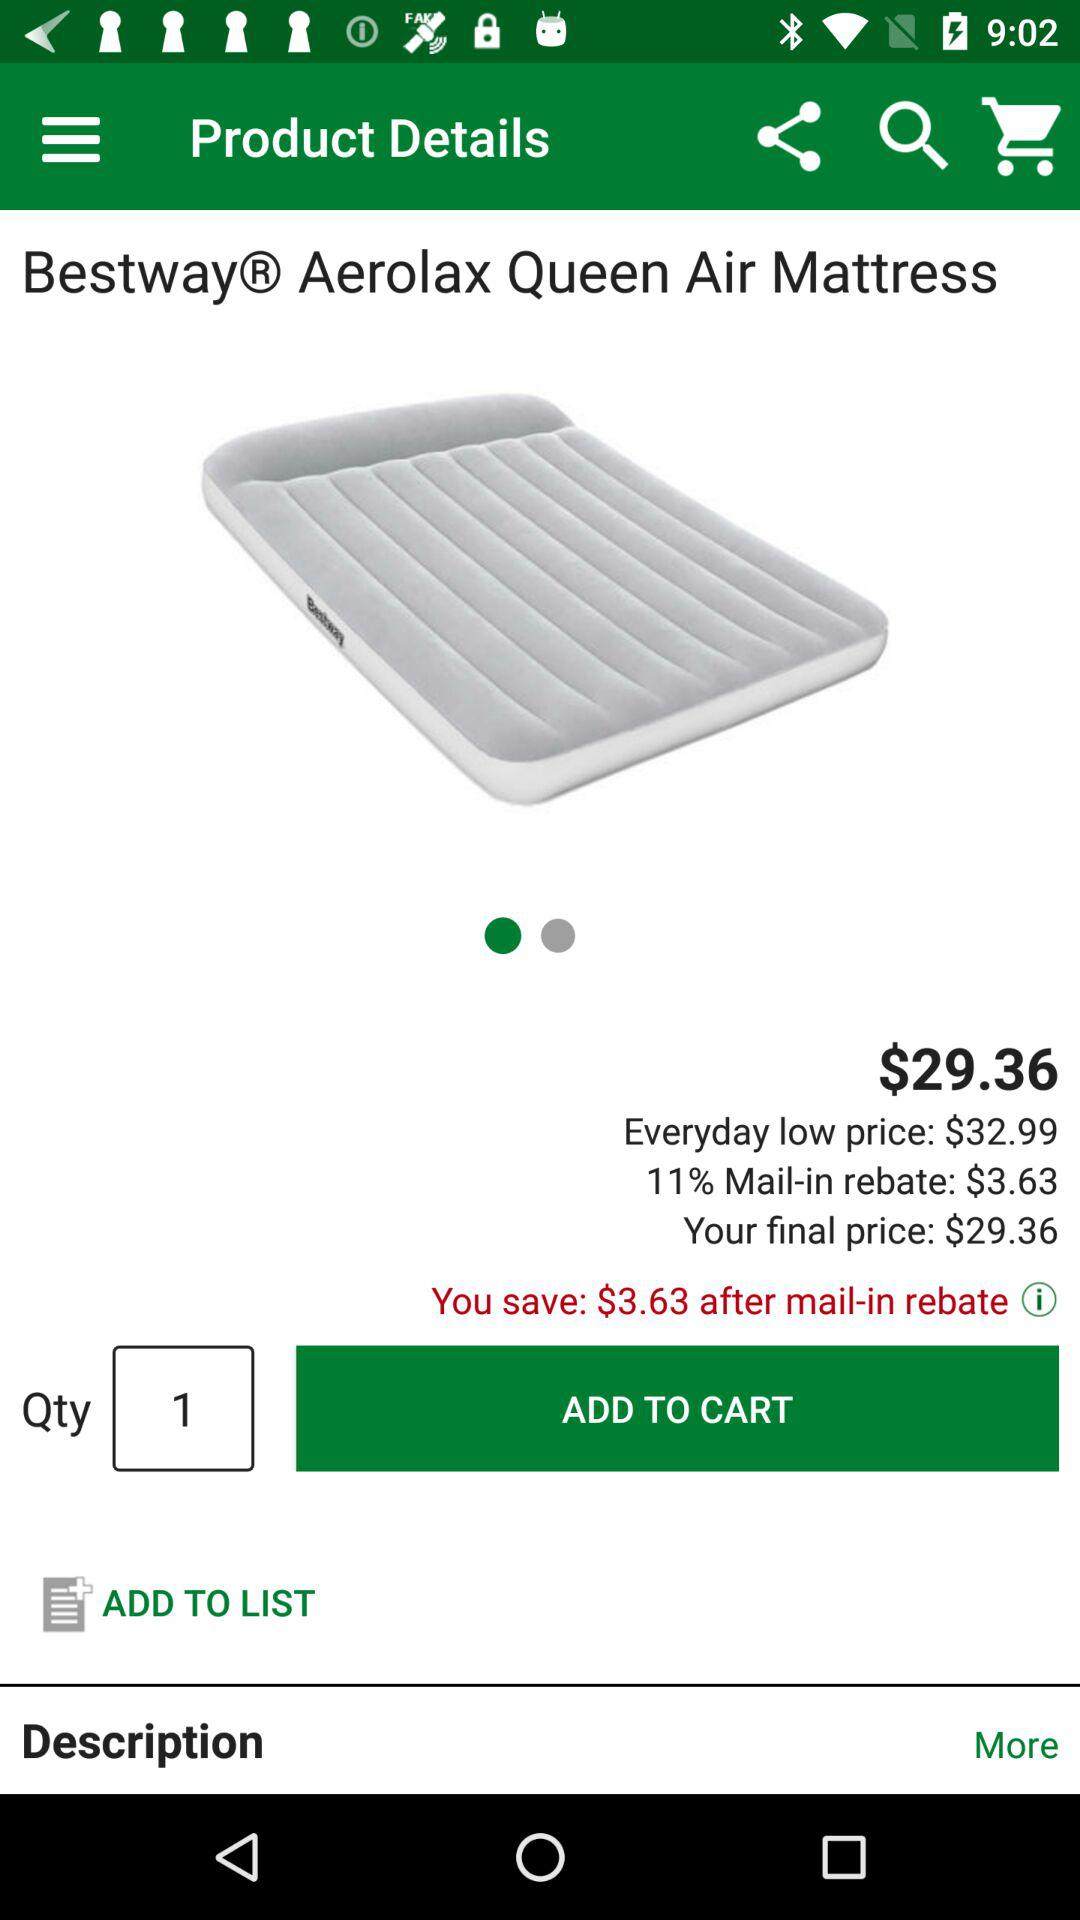How much is the final price of the item?
Answer the question using a single word or phrase. $29.36 